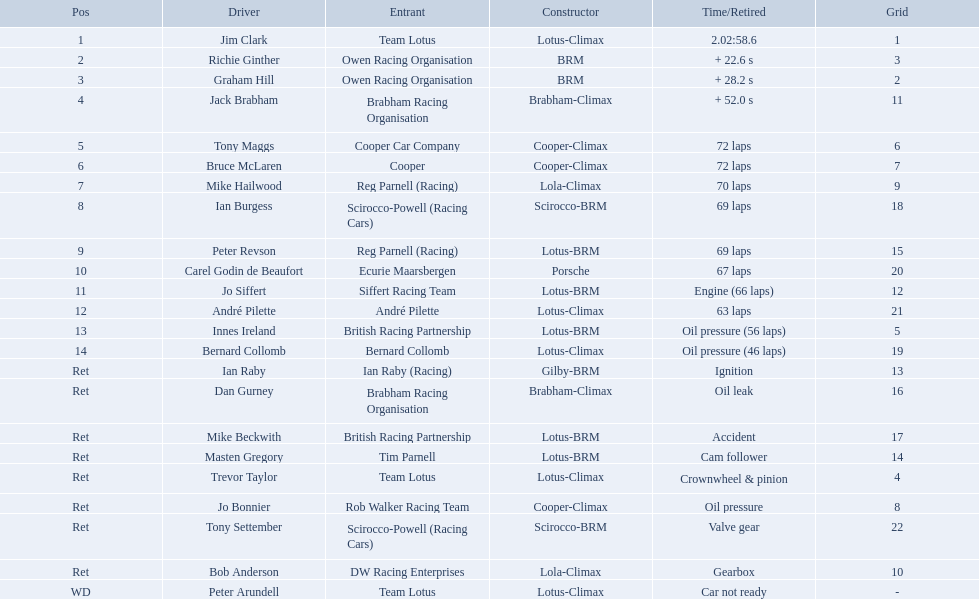Who are all the drivers? Jim Clark, Richie Ginther, Graham Hill, Jack Brabham, Tony Maggs, Bruce McLaren, Mike Hailwood, Ian Burgess, Peter Revson, Carel Godin de Beaufort, Jo Siffert, André Pilette, Innes Ireland, Bernard Collomb, Ian Raby, Dan Gurney, Mike Beckwith, Masten Gregory, Trevor Taylor, Jo Bonnier, Tony Settember, Bob Anderson, Peter Arundell. What position were they in? 1, 2, 3, 4, 5, 6, 7, 8, 9, 10, 11, 12, 13, 14, Ret, Ret, Ret, Ret, Ret, Ret, Ret, Ret, WD. What about just tony maggs and jo siffert? 5, 11. And between them, which driver came in earlier? Tony Maggs. Who all drive cars that were constructed bur climax? Jim Clark, Jack Brabham, Tony Maggs, Bruce McLaren, Mike Hailwood, André Pilette, Bernard Collomb, Dan Gurney, Trevor Taylor, Jo Bonnier, Bob Anderson, Peter Arundell. Which driver's climax constructed cars started in the top 10 on the grid? Jim Clark, Tony Maggs, Bruce McLaren, Mike Hailwood, Jo Bonnier, Bob Anderson. Of the top 10 starting climax constructed drivers, which ones did not finish the race? Jo Bonnier, Bob Anderson. What was the failure that was engine related that took out the driver of the climax constructed car that did not finish even though it started in the top 10? Oil pressure. Who drove in the 1963 international gold cup? Jim Clark, Richie Ginther, Graham Hill, Jack Brabham, Tony Maggs, Bruce McLaren, Mike Hailwood, Ian Burgess, Peter Revson, Carel Godin de Beaufort, Jo Siffert, André Pilette, Innes Ireland, Bernard Collomb, Ian Raby, Dan Gurney, Mike Beckwith, Masten Gregory, Trevor Taylor, Jo Bonnier, Tony Settember, Bob Anderson, Peter Arundell. Who had problems during the race? Jo Siffert, Innes Ireland, Bernard Collomb, Ian Raby, Dan Gurney, Mike Beckwith, Masten Gregory, Trevor Taylor, Jo Bonnier, Tony Settember, Bob Anderson, Peter Arundell. Of those who was still able to finish the race? Jo Siffert, Innes Ireland, Bernard Collomb. Of those who faced the same issue? Innes Ireland, Bernard Collomb. What issue did they have? Oil pressure. Who are all the participants driving? Jim Clark, Richie Ginther, Graham Hill, Jack Brabham, Tony Maggs, Bruce McLaren, Mike Hailwood, Ian Burgess, Peter Revson, Carel Godin de Beaufort, Jo Siffert, André Pilette, Innes Ireland, Bernard Collomb, Ian Raby, Dan Gurney, Mike Beckwith, Masten Gregory, Trevor Taylor, Jo Bonnier, Tony Settember, Bob Anderson, Peter Arundell. What were their rankings? 1, 2, 3, 4, 5, 6, 7, 8, 9, 10, 11, 12, 13, 14, Ret, Ret, Ret, Ret, Ret, Ret, Ret, Ret, WD. What are all the manufacturer names? Lotus-Climax, BRM, BRM, Brabham-Climax, Cooper-Climax, Cooper-Climax, Lola-Climax, Scirocco-BRM, Lotus-BRM, Porsche, Lotus-BRM, Lotus-Climax, Lotus-BRM, Lotus-Climax, Gilby-BRM, Brabham-Climax, Lotus-BRM, Lotus-BRM, Lotus-Climax, Cooper-Climax, Scirocco-BRM, Lola-Climax, Lotus-Climax. And which participants drove a cooper-climax? Tony Maggs, Bruce McLaren. Among those two, who had a higher position? Tony Maggs. Who were the racers at the 1963 international gold cup? Jim Clark, Richie Ginther, Graham Hill, Jack Brabham, Tony Maggs, Bruce McLaren, Mike Hailwood, Ian Burgess, Peter Revson, Carel Godin de Beaufort, Jo Siffert, André Pilette, Innes Ireland, Bernard Collomb, Ian Raby, Dan Gurney, Mike Beckwith, Masten Gregory, Trevor Taylor, Jo Bonnier, Tony Settember, Bob Anderson, Peter Arundell. What was tony maggs' standing? 5. What about jo siffert? 11. Who finished earlier? Tony Maggs. Who were the duo that faced a related challenge? Innes Ireland. What was their shared predicament? Oil pressure. Write the full table. {'header': ['Pos', 'Driver', 'Entrant', 'Constructor', 'Time/Retired', 'Grid'], 'rows': [['1', 'Jim Clark', 'Team Lotus', 'Lotus-Climax', '2.02:58.6', '1'], ['2', 'Richie Ginther', 'Owen Racing Organisation', 'BRM', '+ 22.6 s', '3'], ['3', 'Graham Hill', 'Owen Racing Organisation', 'BRM', '+ 28.2 s', '2'], ['4', 'Jack Brabham', 'Brabham Racing Organisation', 'Brabham-Climax', '+ 52.0 s', '11'], ['5', 'Tony Maggs', 'Cooper Car Company', 'Cooper-Climax', '72 laps', '6'], ['6', 'Bruce McLaren', 'Cooper', 'Cooper-Climax', '72 laps', '7'], ['7', 'Mike Hailwood', 'Reg Parnell (Racing)', 'Lola-Climax', '70 laps', '9'], ['8', 'Ian Burgess', 'Scirocco-Powell (Racing Cars)', 'Scirocco-BRM', '69 laps', '18'], ['9', 'Peter Revson', 'Reg Parnell (Racing)', 'Lotus-BRM', '69 laps', '15'], ['10', 'Carel Godin de Beaufort', 'Ecurie Maarsbergen', 'Porsche', '67 laps', '20'], ['11', 'Jo Siffert', 'Siffert Racing Team', 'Lotus-BRM', 'Engine (66 laps)', '12'], ['12', 'André Pilette', 'André Pilette', 'Lotus-Climax', '63 laps', '21'], ['13', 'Innes Ireland', 'British Racing Partnership', 'Lotus-BRM', 'Oil pressure (56 laps)', '5'], ['14', 'Bernard Collomb', 'Bernard Collomb', 'Lotus-Climax', 'Oil pressure (46 laps)', '19'], ['Ret', 'Ian Raby', 'Ian Raby (Racing)', 'Gilby-BRM', 'Ignition', '13'], ['Ret', 'Dan Gurney', 'Brabham Racing Organisation', 'Brabham-Climax', 'Oil leak', '16'], ['Ret', 'Mike Beckwith', 'British Racing Partnership', 'Lotus-BRM', 'Accident', '17'], ['Ret', 'Masten Gregory', 'Tim Parnell', 'Lotus-BRM', 'Cam follower', '14'], ['Ret', 'Trevor Taylor', 'Team Lotus', 'Lotus-Climax', 'Crownwheel & pinion', '4'], ['Ret', 'Jo Bonnier', 'Rob Walker Racing Team', 'Cooper-Climax', 'Oil pressure', '8'], ['Ret', 'Tony Settember', 'Scirocco-Powell (Racing Cars)', 'Scirocco-BRM', 'Valve gear', '22'], ['Ret', 'Bob Anderson', 'DW Racing Enterprises', 'Lola-Climax', 'Gearbox', '10'], ['WD', 'Peter Arundell', 'Team Lotus', 'Lotus-Climax', 'Car not ready', '-']]} Who all operate vehicles built by climax? Jim Clark, Jack Brabham, Tony Maggs, Bruce McLaren, Mike Hailwood, André Pilette, Bernard Collomb, Dan Gurney, Trevor Taylor, Jo Bonnier, Bob Anderson, Peter Arundell. Which pilot's climax-built cars commenced in the top 10 on the grid? Jim Clark, Tony Maggs, Bruce McLaren, Mike Hailwood, Jo Bonnier, Bob Anderson. Of the top 10 starting climax-built racers, which ones did not complete the competition? Jo Bonnier, Bob Anderson. What was the engine-related issue that eliminated the driver of the climax-built vehicle that could not finish, even though it began in the top 10? Oil pressure. Which two people experienced a comparable problem? Innes Ireland. What was the shared problem between them? Oil pressure. 